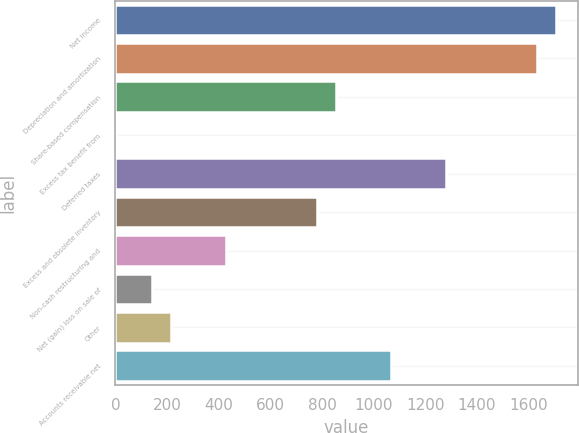Convert chart to OTSL. <chart><loc_0><loc_0><loc_500><loc_500><bar_chart><fcel>Net income<fcel>Depreciation and amortization<fcel>Share-based compensation<fcel>Excess tax benefit from<fcel>Deferred taxes<fcel>Excess and obsolete inventory<fcel>Non-cash restructuring and<fcel>Net (gain) loss on sale of<fcel>Other<fcel>Accounts receivable net<nl><fcel>1705<fcel>1634<fcel>853<fcel>1<fcel>1279<fcel>782<fcel>427<fcel>143<fcel>214<fcel>1066<nl></chart> 